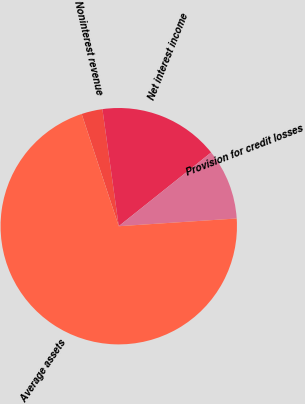<chart> <loc_0><loc_0><loc_500><loc_500><pie_chart><fcel>Noninterest revenue<fcel>Net interest income<fcel>Provision for credit losses<fcel>Average assets<nl><fcel>2.87%<fcel>16.49%<fcel>9.68%<fcel>70.96%<nl></chart> 